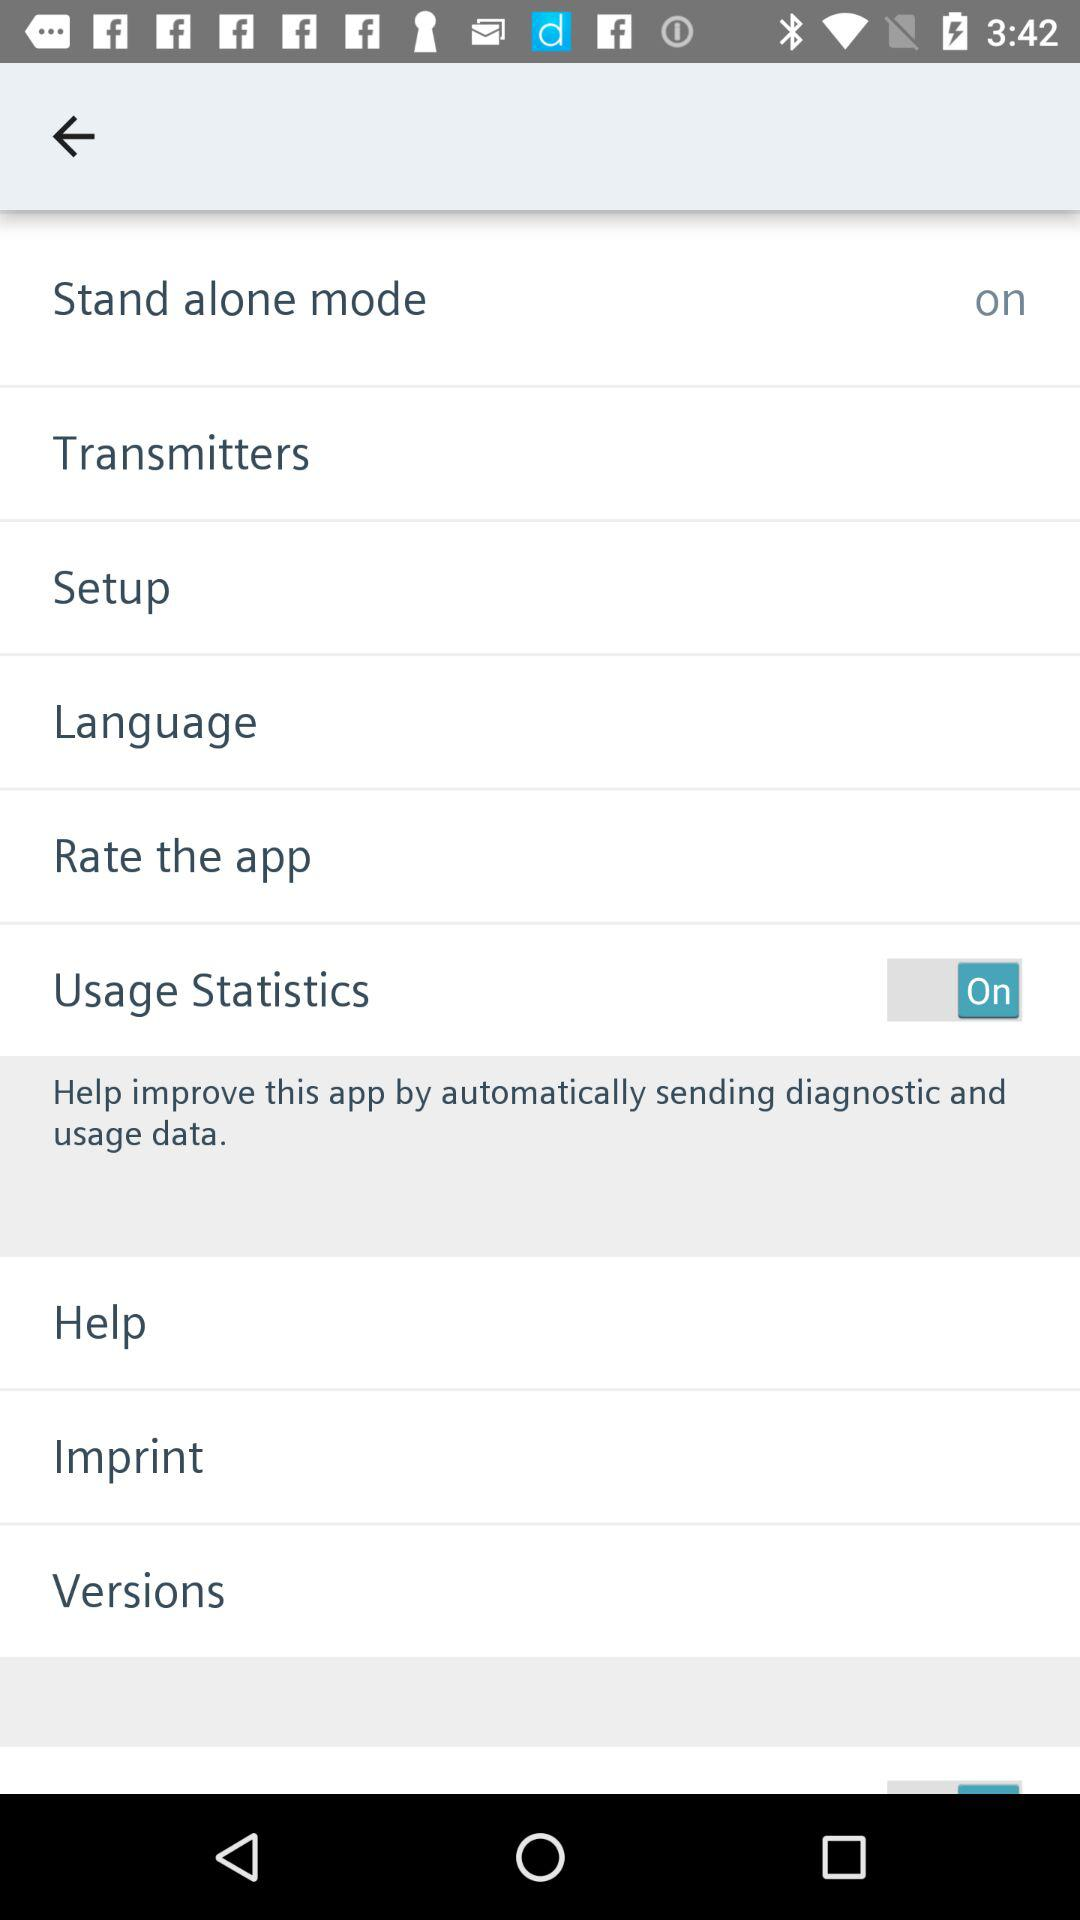What is the status of "Stand alone mode"? The status is "on". 